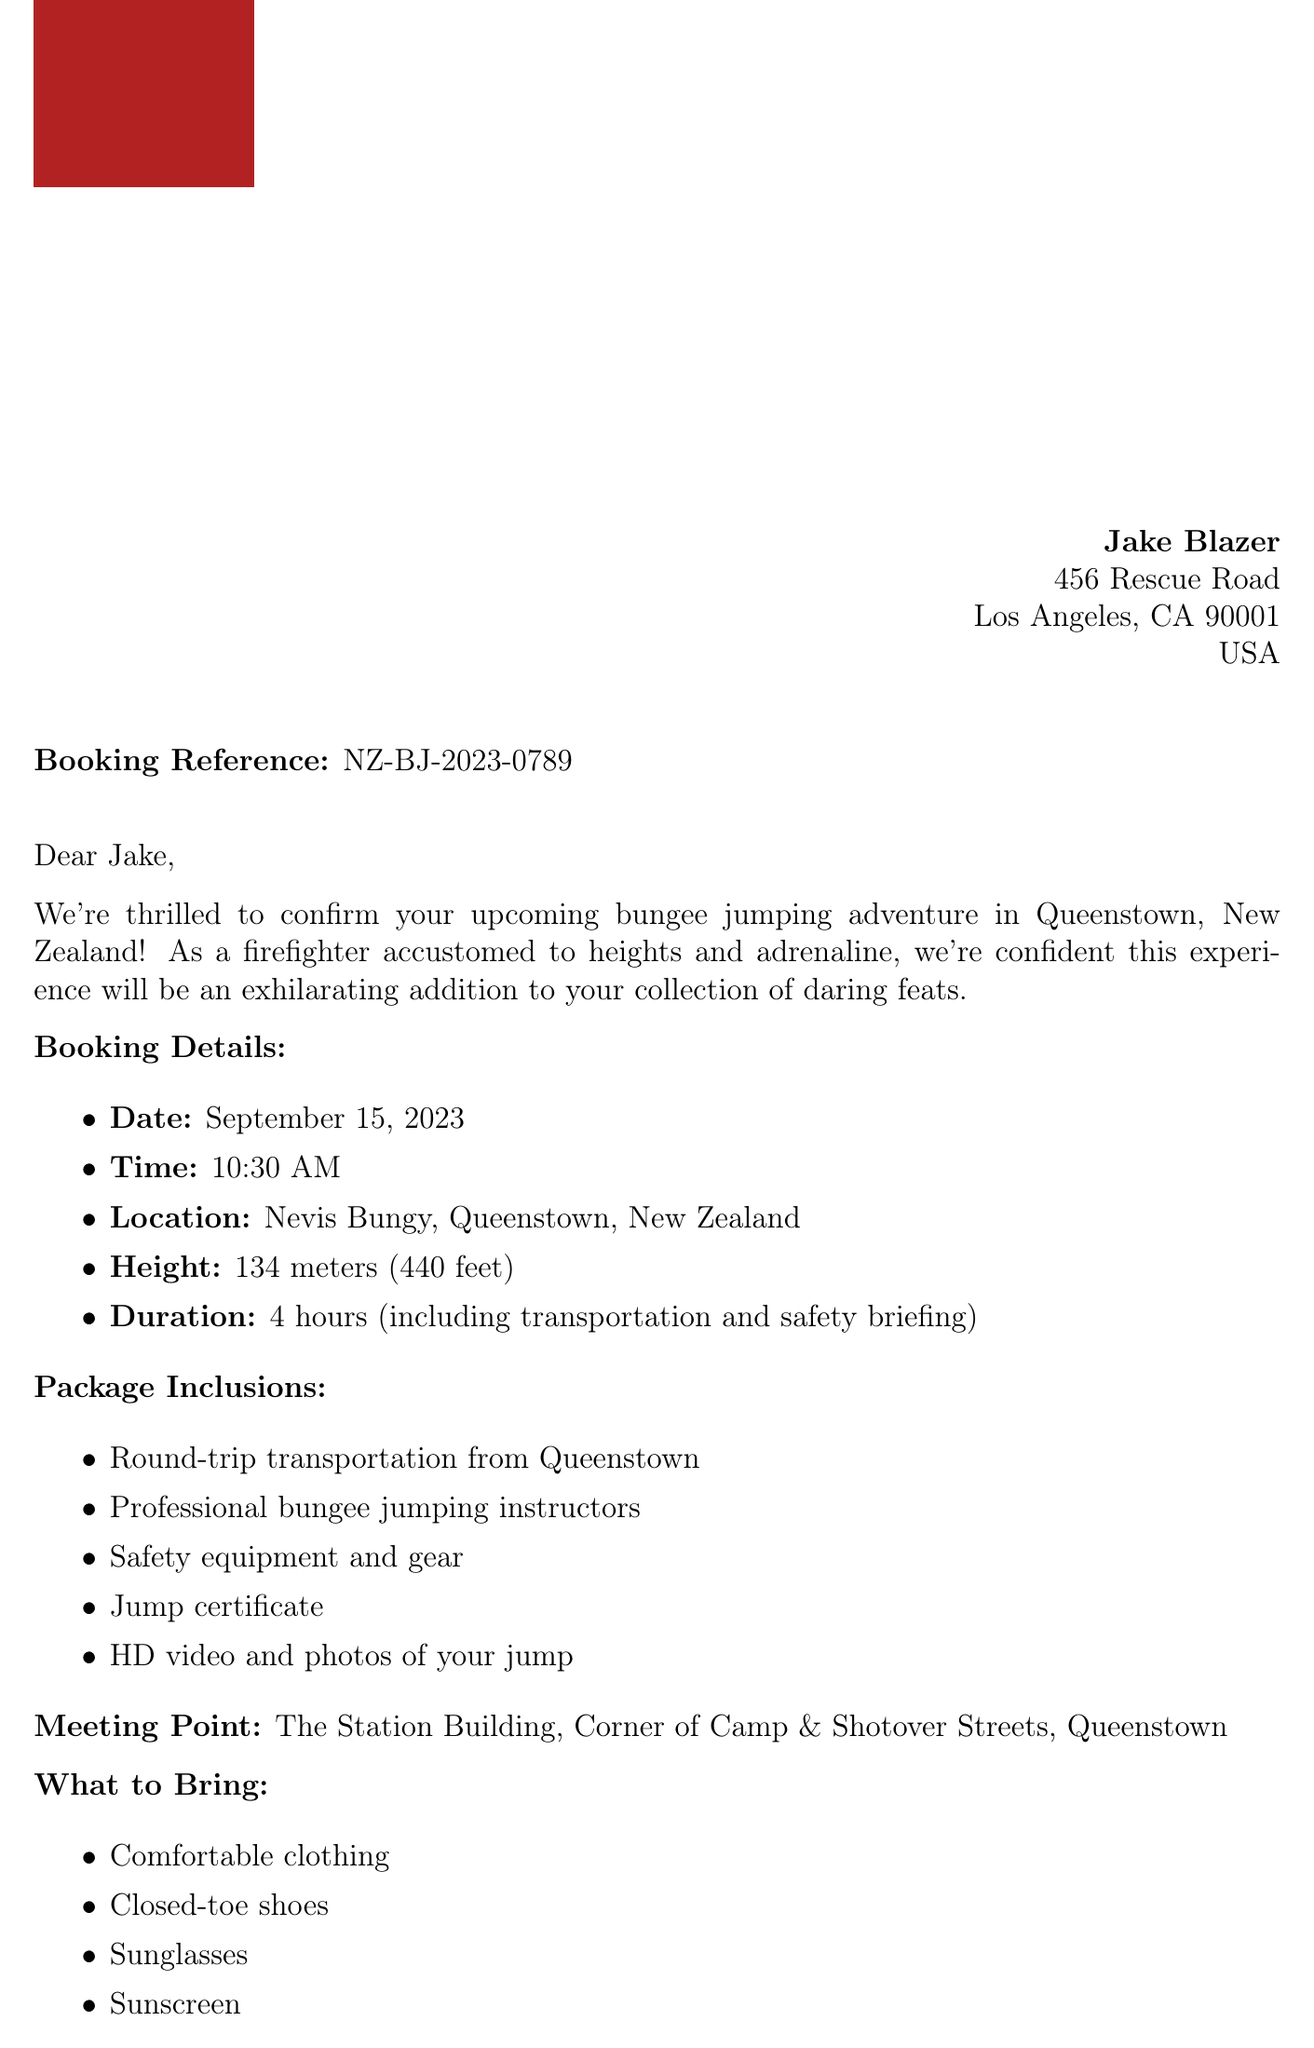What is the agency name? The document specifies the agency Name in the heading as "Kiwi Extreme Adventures."
Answer: Kiwi Extreme Adventures What is the height of the bungee jump? The document includes a specific height for the bungee jump, which is listed as "134 meters (440 feet)."
Answer: 134 meters (440 feet) What is the total cost for the bungee jump? The total cost is explicitly mentioned in the payment information section as "NZD 295."
Answer: NZD 295 What is the balance due? The balance due is identified in the payment information as "NZD 195."
Answer: NZD 195 What is the meeting point for the adventure? The document provides the meeting point as "The Station Building, Corner of Camp & Shotover Streets, Queenstown."
Answer: The Station Building, Corner of Camp & Shotover Streets, Queenstown How long is the bungee jumping adventure? The duration of the bungee jumping experience is mentioned as "4 hours (including transportation and safety briefing)."
Answer: 4 hours Is there a minimum age requirement for participants? The document specifies an age requirement in the additional information section as "Minimum 13 years old."
Answer: Minimum 13 years old What is included in the package? The package inclusions are clearly listed, including various services such as transportation and a jump certificate.
Answer: Round-trip transportation, Professional bungee jumping instructors, Safety equipment and gear, Jump certificate, HD video and photos What is the cancellation policy for a full refund? The cancellation policy indicates a full refund applies "Up to 72 hours before the scheduled jump."
Answer: Up to 72 hours before the scheduled jump 